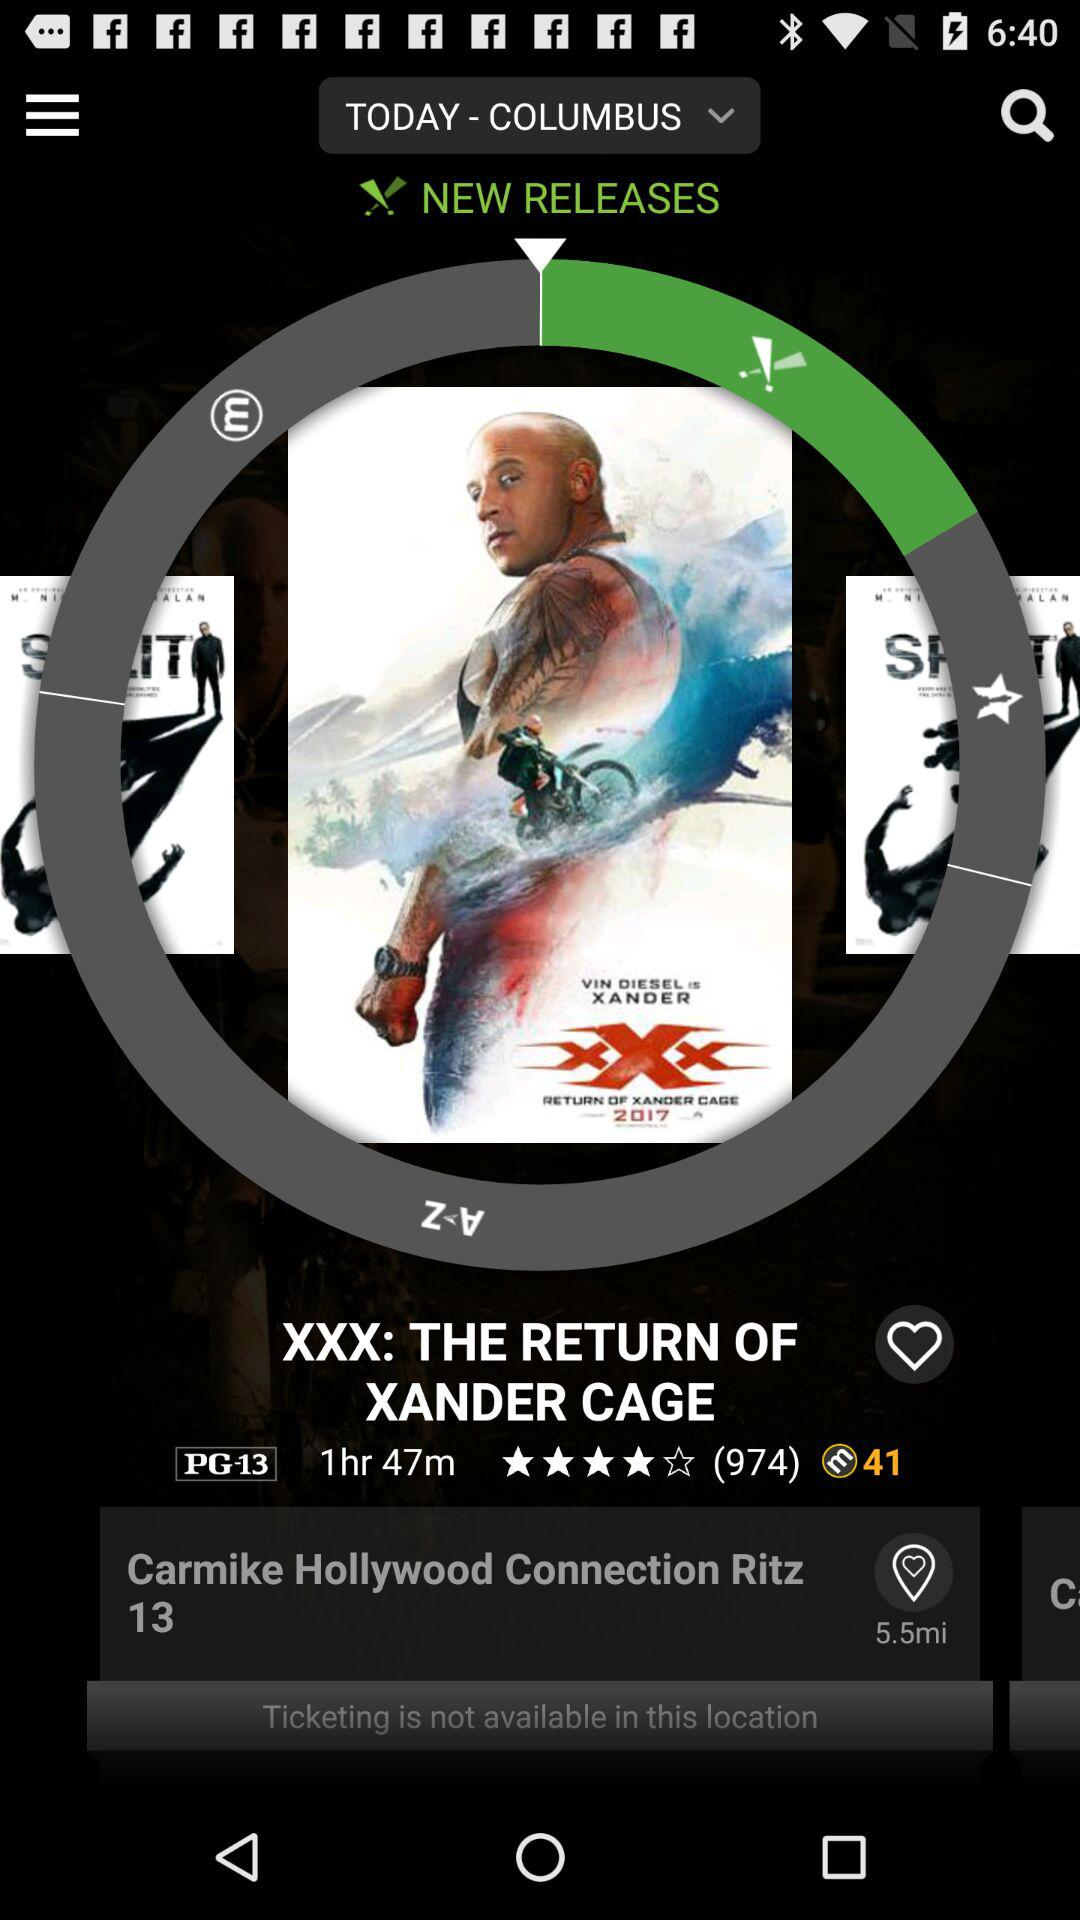What location does not have a ticketing facility? The location which does not have a ticketing facility is "Carmike Hollywood Connection Ritz 13". 